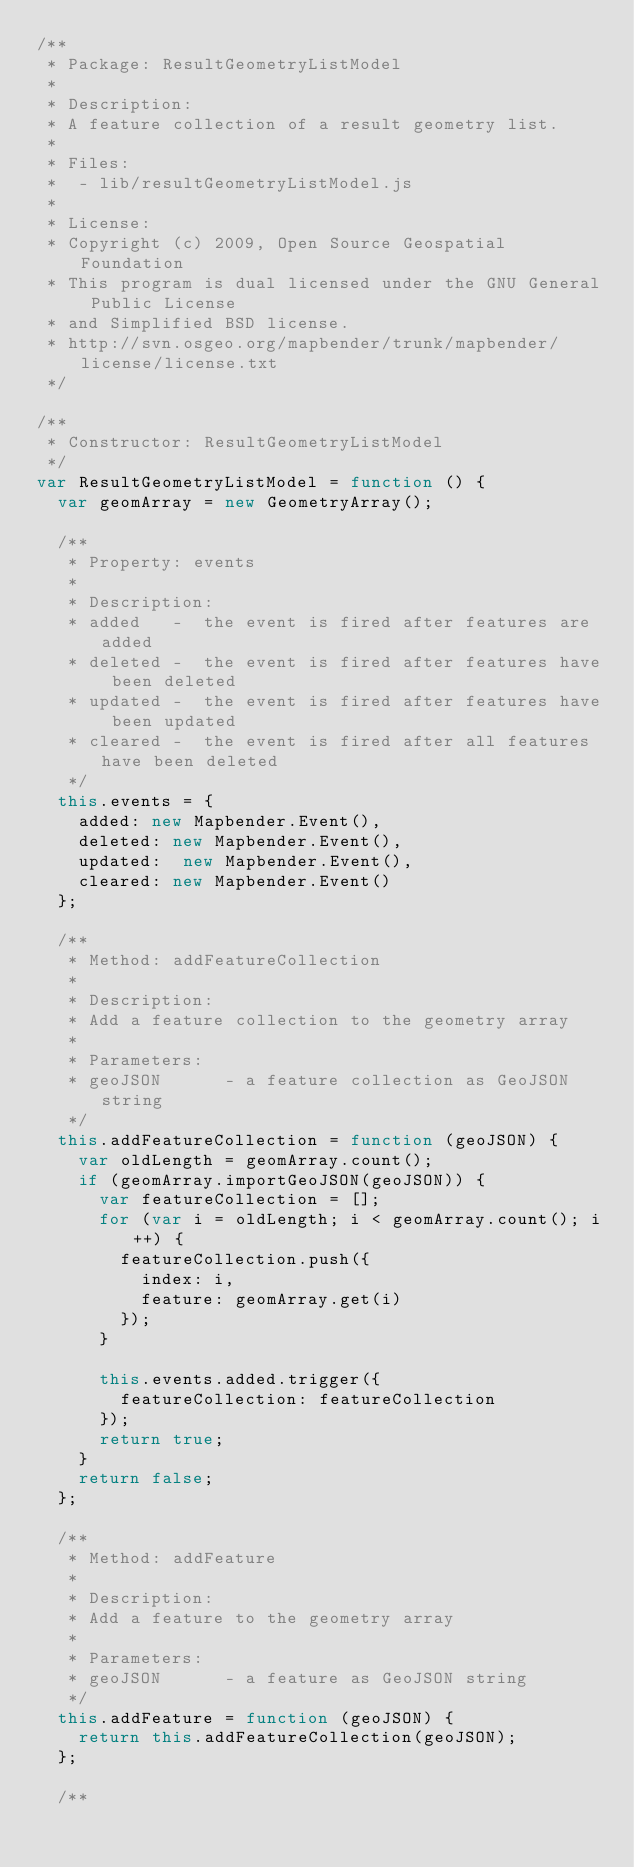Convert code to text. <code><loc_0><loc_0><loc_500><loc_500><_JavaScript_>/**
 * Package: ResultGeometryListModel
 * 
 * Description:
 * A feature collection of a result geometry list.
 * 
 * Files:
 *  - lib/resultGeometryListModel.js
 *
 * License:
 * Copyright (c) 2009, Open Source Geospatial Foundation
 * This program is dual licensed under the GNU General Public License 
 * and Simplified BSD license.  
 * http://svn.osgeo.org/mapbender/trunk/mapbender/license/license.txt
 */

/**
 * Constructor: ResultGeometryListModel
 */
var ResultGeometryListModel = function () {
	var geomArray = new GeometryArray();

	/**
	 * Property: events
	 * 
	 * Description:
	 * added   -  the event is fired after features are added
	 * deleted -  the event is fired after features have been deleted
	 * updated -  the event is fired after features have been updated
	 * cleared -  the event is fired after all features have been deleted
	 */
	this.events = {
		added: new Mapbender.Event(),
		deleted: new Mapbender.Event(),
		updated:  new Mapbender.Event(),
		cleared: new Mapbender.Event()
	};

	/**
	 * Method: addFeatureCollection
	 * 
	 * Description:
	 * Add a feature collection to the geometry array
	 * 
	 * Parameters:
	 * geoJSON      - a feature collection as GeoJSON string
	 */
	this.addFeatureCollection = function (geoJSON) {
		var oldLength = geomArray.count();
		if (geomArray.importGeoJSON(geoJSON)) {
			var featureCollection = [];
			for (var i = oldLength; i < geomArray.count(); i++) {
				featureCollection.push({
					index: i,
					feature: geomArray.get(i)
				});
			}
			
			this.events.added.trigger({
				featureCollection: featureCollection
			});
			return true;
		}
		return false;
	};

	/**
	 * Method: addFeature
	 * 
	 * Description:
	 * Add a feature to the geometry array
	 * 
	 * Parameters:
	 * geoJSON      - a feature as GeoJSON string
	 */
	this.addFeature = function (geoJSON) {
		return this.addFeatureCollection(geoJSON);
	};
	
	/**</code> 